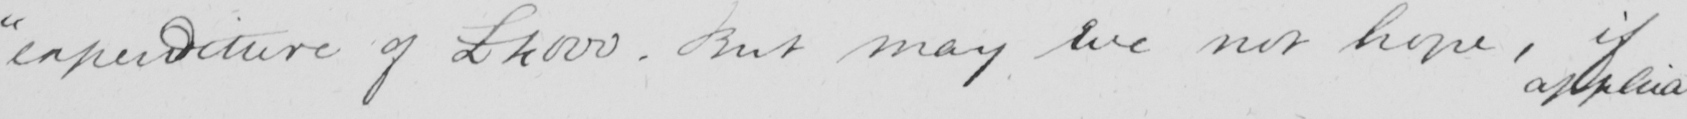What text is written in this handwritten line? " expenditure of £4000 . But may we not hope , if 